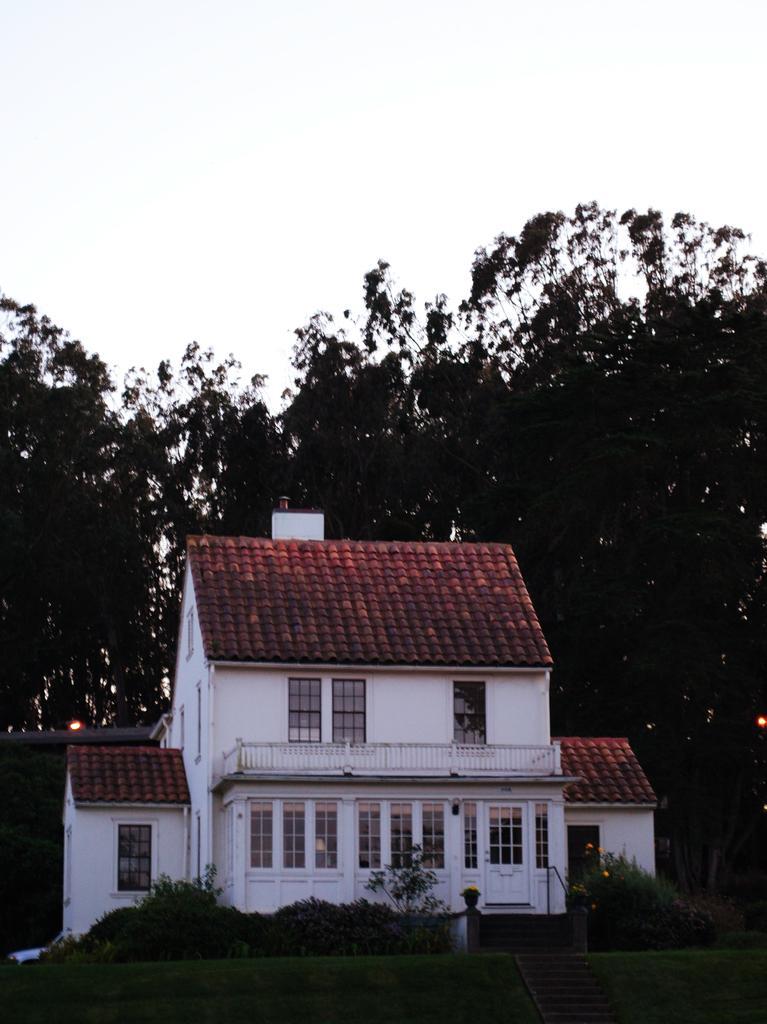Could you give a brief overview of what you see in this image? There is a beautiful house and there is a garden in front of the house,in the background there are plenty of trees. 